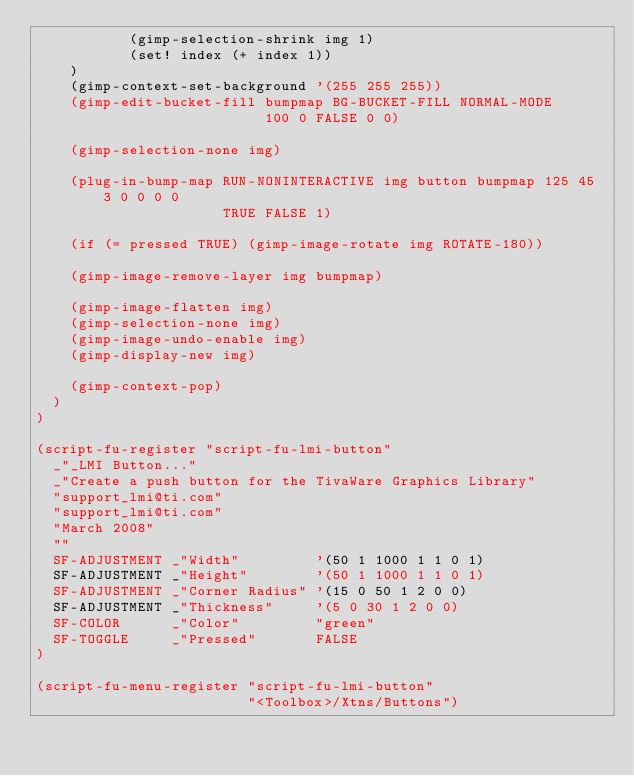Convert code to text. <code><loc_0><loc_0><loc_500><loc_500><_Scheme_>           (gimp-selection-shrink img 1)
           (set! index (+ index 1))
    )
    (gimp-context-set-background '(255 255 255))
    (gimp-edit-bucket-fill bumpmap BG-BUCKET-FILL NORMAL-MODE
                           100 0 FALSE 0 0)

    (gimp-selection-none img)

    (plug-in-bump-map RUN-NONINTERACTIVE img button bumpmap 125 45 3 0 0 0 0
                      TRUE FALSE 1)

    (if (= pressed TRUE) (gimp-image-rotate img ROTATE-180))

    (gimp-image-remove-layer img bumpmap)

    (gimp-image-flatten img)
    (gimp-selection-none img)
    (gimp-image-undo-enable img)
    (gimp-display-new img)

    (gimp-context-pop)
  )
)

(script-fu-register "script-fu-lmi-button"
  _"_LMI Button..."
  _"Create a push button for the TivaWare Graphics Library"
  "support_lmi@ti.com"
  "support_lmi@ti.com"
  "March 2008"
  ""
  SF-ADJUSTMENT _"Width"         '(50 1 1000 1 1 0 1)
  SF-ADJUSTMENT _"Height"        '(50 1 1000 1 1 0 1)
  SF-ADJUSTMENT _"Corner Radius" '(15 0 50 1 2 0 0)
  SF-ADJUSTMENT _"Thickness"     '(5 0 30 1 2 0 0)
  SF-COLOR      _"Color"         "green"
  SF-TOGGLE     _"Pressed"       FALSE
)

(script-fu-menu-register "script-fu-lmi-button"
                         "<Toolbox>/Xtns/Buttons")
</code> 